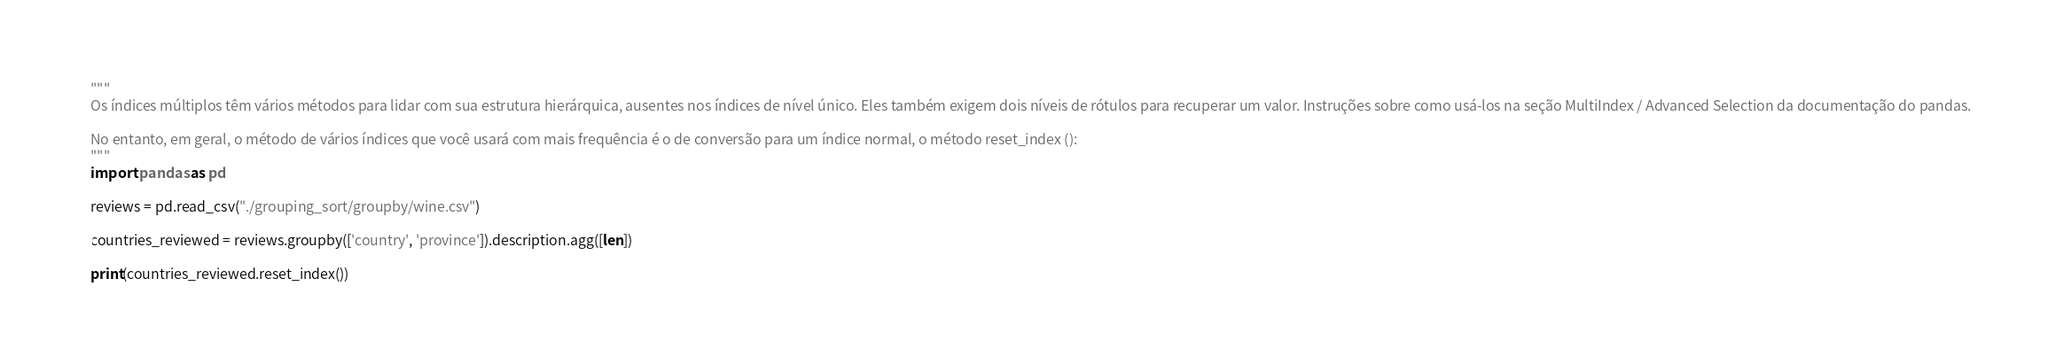<code> <loc_0><loc_0><loc_500><loc_500><_Python_>"""
Os índices múltiplos têm vários métodos para lidar com sua estrutura hierárquica, ausentes nos índices de nível único. Eles também exigem dois níveis de rótulos para recuperar um valor. Instruções sobre como usá-los na seção MultiIndex / Advanced Selection da documentação do pandas.

No entanto, em geral, o método de vários índices que você usará com mais frequência é o de conversão para um índice normal, o método reset_index ():
"""
import pandas as pd 

reviews = pd.read_csv("./grouping_sort/groupby/wine.csv")

countries_reviewed = reviews.groupby(['country', 'province']).description.agg([len])

print(countries_reviewed.reset_index())</code> 